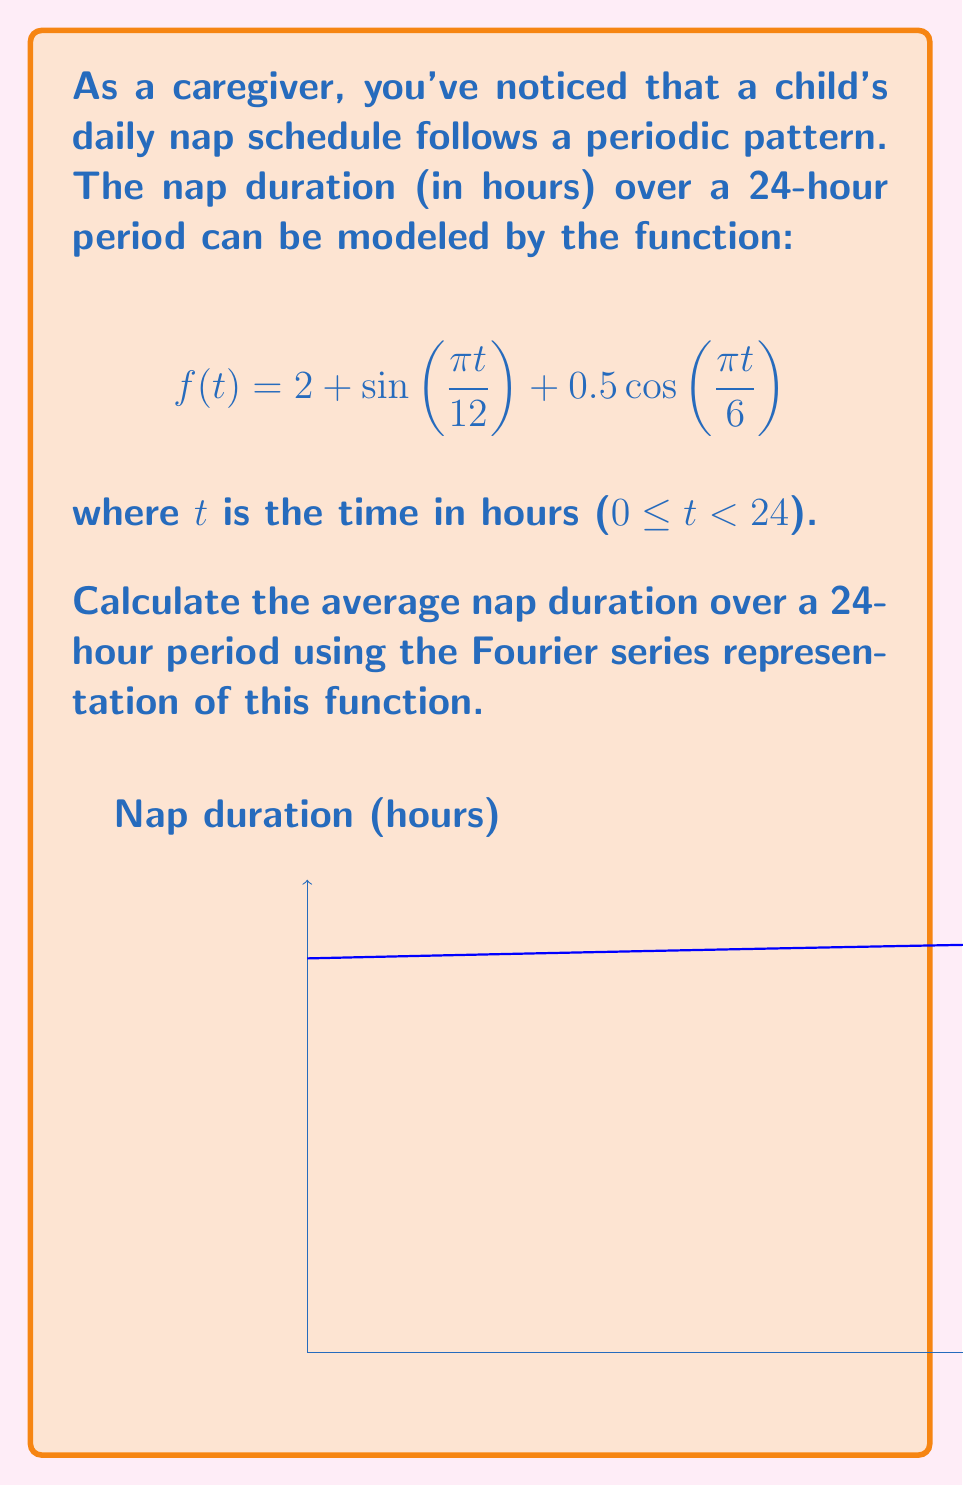Can you answer this question? To solve this problem, we'll follow these steps:

1) Recall that the average value of a periodic function over one period is equal to the constant term (a₀) in its Fourier series representation.

2) For a function defined over the interval [0, L], the constant term a₀ is given by:

   $$a_0 = \frac{1}{L} \int_0^L f(t) dt$$

3) In our case, L = 24 (the period is 24 hours). So we need to calculate:

   $$a_0 = \frac{1}{24} \int_0^{24} f(t) dt$$

4) Substituting our function:

   $$a_0 = \frac{1}{24} \int_0^{24} \left(2 + \sin\left(\frac{\pi t}{12}\right) + 0.5\cos\left(\frac{\pi t}{6}\right)\right) dt$$

5) We can split this into three integrals:

   $$a_0 = \frac{1}{24} \left[\int_0^{24} 2 dt + \int_0^{24} \sin\left(\frac{\pi t}{12}\right) dt + \int_0^{24} 0.5\cos\left(\frac{\pi t}{6}\right) dt\right]$$

6) Solving each integral:
   
   - $\int_0^{24} 2 dt = 2t \big|_0^{24} = 48$
   
   - $\int_0^{24} \sin\left(\frac{\pi t}{12}\right) dt = -\frac{12}{\pi} \cos\left(\frac{\pi t}{12}\right) \big|_0^{24} = 0$
   
   - $\int_0^{24} 0.5\cos\left(\frac{\pi t}{6}\right) dt = 0.5 \cdot \frac{6}{\pi} \sin\left(\frac{\pi t}{6}\right) \big|_0^{24} = 0$

7) Therefore:

   $$a_0 = \frac{1}{24} [48 + 0 + 0] = 2$$

Thus, the average nap duration over a 24-hour period is 2 hours.
Answer: 2 hours 